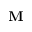<formula> <loc_0><loc_0><loc_500><loc_500>M</formula> 